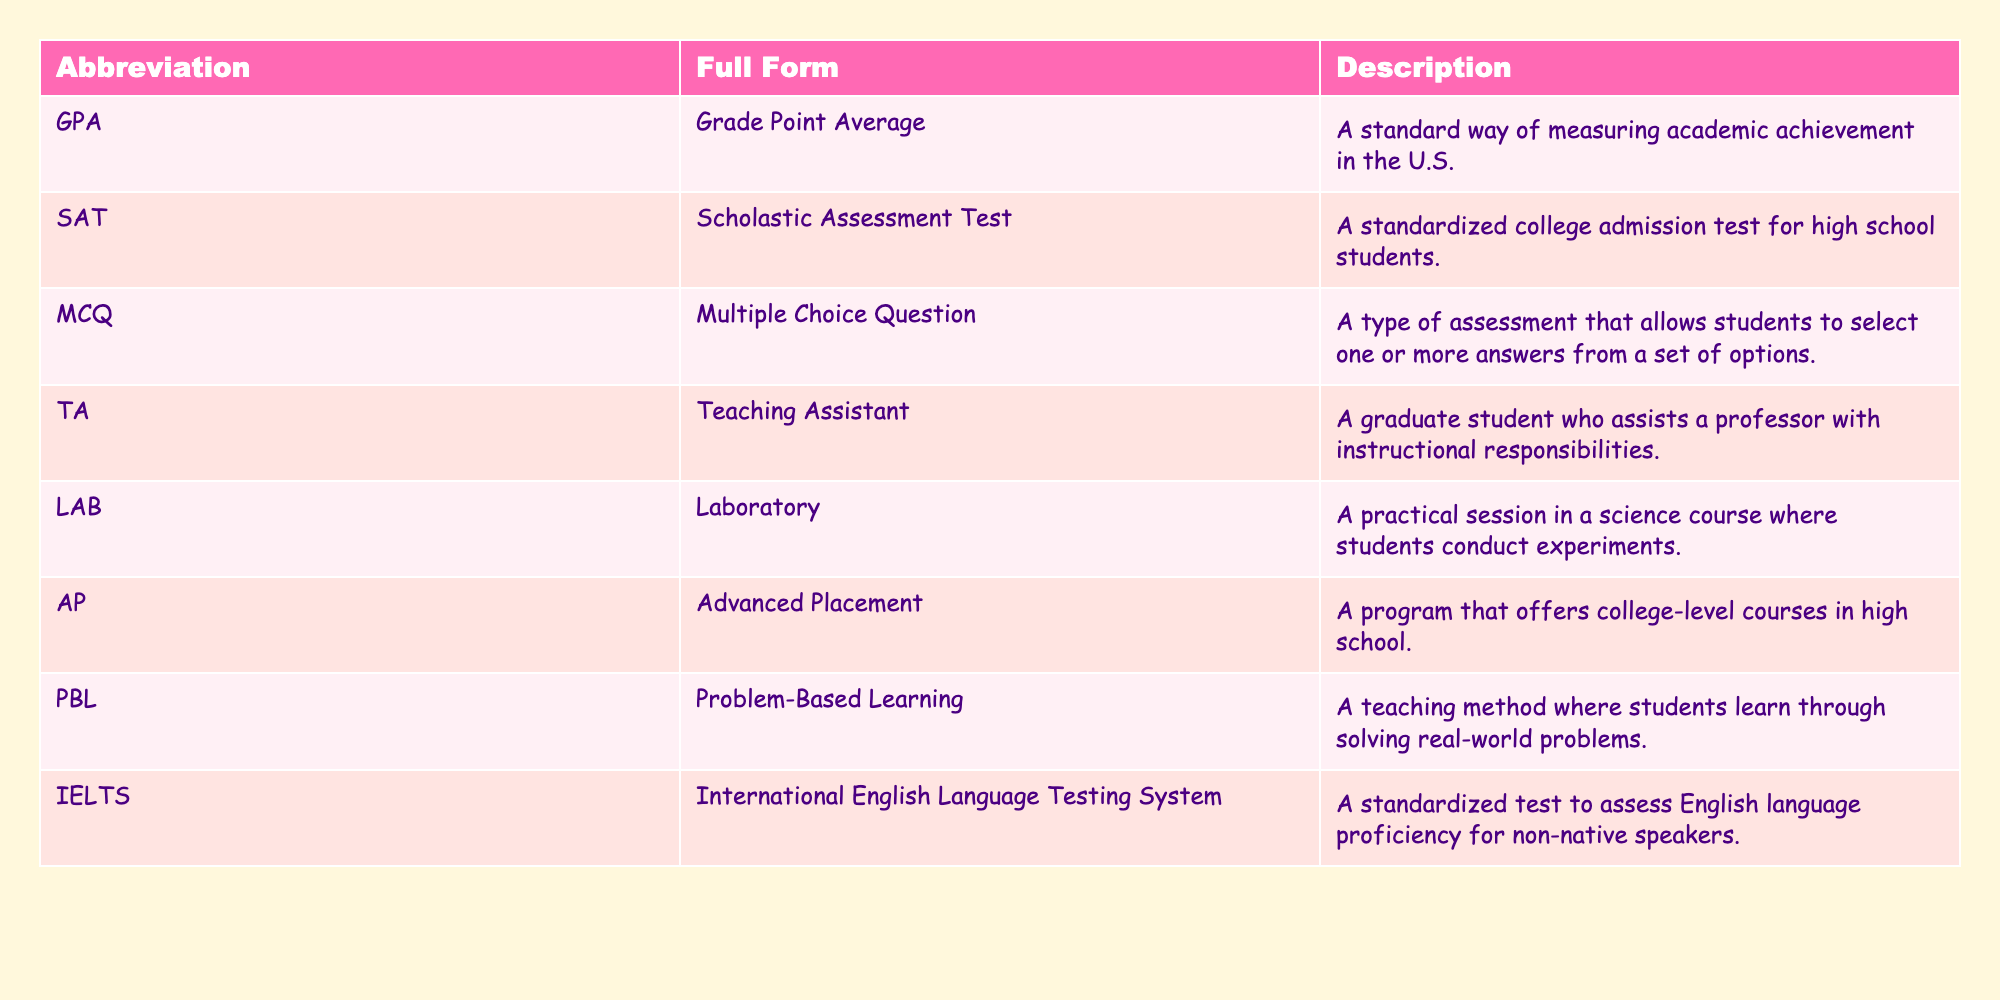What does GPA stand for? From the table, the abbreviation "GPA" is listed in the first column, and its full form "Grade Point Average" is presented in the second column.
Answer: Grade Point Average What is the description of the SAT? The SAT is found in the abbreviation column, and its description can be found in the same row under the description column, which states it is a standardized college admission test for high school students.
Answer: A standardized college admission test for high school students Is a TA a full-time position? Looking at the description of "TA" in the table, it states that a TA, or Teaching Assistant, is a graduate student who assists a professor. This implies that it is not a full-time position as it refers to graduate students.
Answer: No How many abbreviations listed are related to English language proficiency? Upon examining the table, "IELTS" is the only abbreviation that relates to English language proficiency. Therefore, we can count this as one.
Answer: 1 Which abbreviation has a focus on practical work in a science course? In the table, "LAB" stands out as it indicates a practical session in a science course where experiments are conducted, directly associated with this focus.
Answer: LAB Are there any abbreviations that indicate a type of assessment? When we look at the table, both "MCQ" (Multiple Choice Question) and "SAT" (Scholastic Assessment Test) relate to as assessments. This confirms that there are indeed abbreviations for types of assessments.
Answer: Yes What is the difference between AP and PBL regarding their educational focus? AP, or Advanced Placement, offers college-level courses in high school. In contrast, PBL, or Problem-Based Learning, encourages students to learn through solving real-world problems. The clear difference lies in AP’s focus on college-level academics versus PBL’s emphasis on practical problem-solving.
Answer: AP focuses on college-level courses; PBL focuses on real-world problem-solving If you have both a GPA of 3.5 and a SAT score, how would the SAT affect college admissions? I can infer that a higher SAT score increases the chances of college admission, but the table does not provide numerical values. Generally, college admissions consider both GPA and SAT scores, with a strong GPA helping when combined with a good SAT score. Therefore, having both a GPA of 3.5 and a high SAT score would positively impact admissions.
Answer: SAT positively impacts college admissions 